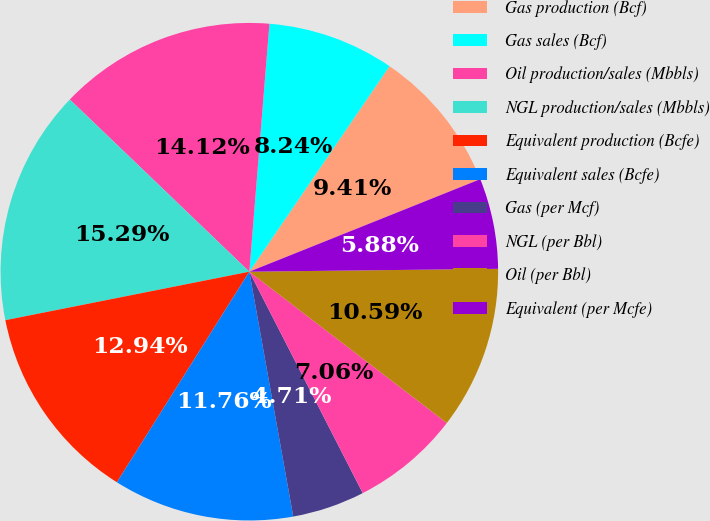<chart> <loc_0><loc_0><loc_500><loc_500><pie_chart><fcel>Gas production (Bcf)<fcel>Gas sales (Bcf)<fcel>Oil production/sales (Mbbls)<fcel>NGL production/sales (Mbbls)<fcel>Equivalent production (Bcfe)<fcel>Equivalent sales (Bcfe)<fcel>Gas (per Mcf)<fcel>NGL (per Bbl)<fcel>Oil (per Bbl)<fcel>Equivalent (per Mcfe)<nl><fcel>9.41%<fcel>8.24%<fcel>14.12%<fcel>15.29%<fcel>12.94%<fcel>11.76%<fcel>4.71%<fcel>7.06%<fcel>10.59%<fcel>5.88%<nl></chart> 